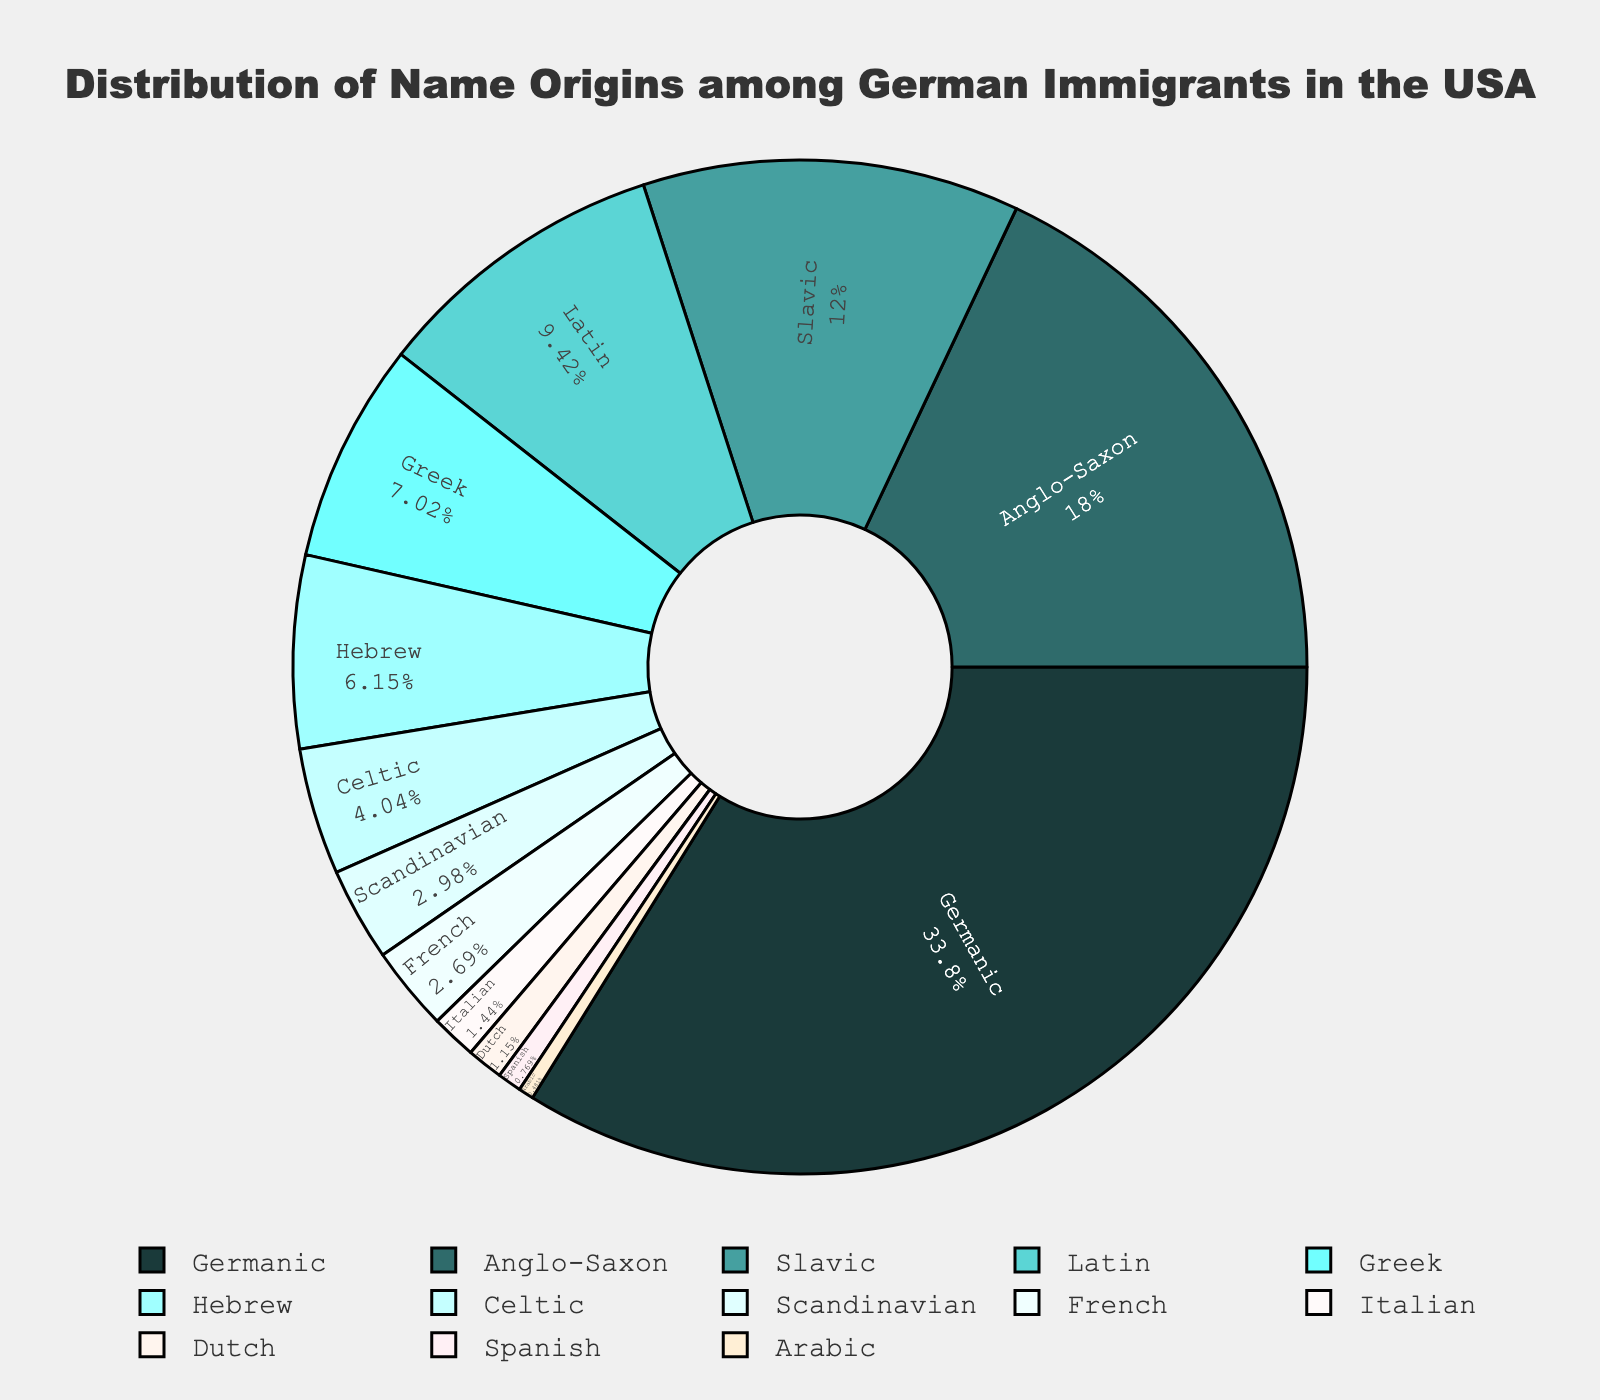What is the most common name origin among German immigrants in the USA? The figure shows the distribution of name origins, with the segment for 'Germanic' being the largest. This indicates that the most common name origin is Germanic.
Answer: Germanic What is the combined percentage of Anglo-Saxon and Slavic name origins among German immigrants in the USA? The figure shows that Anglo-Saxon has a percentage of 18.7% and Slavic has a percentage of 12.5%. Adding these together gives 18.7 + 12.5.
Answer: 31.2% Which name origin has a smaller percentage: Greek or Latin? The figure shows Greek with a percentage of 7.3% and Latin with a percentage of 9.8%. Therefore, Greek has a smaller percentage than Latin.
Answer: Greek How does the percentage of Celtic name origins compare to the percentage of Scandinavian name origins? The figure shows that Celtic is 4.2% and Scandinavian is 3.1%. Celtic has a higher percentage compared to Scandinavian.
Answer: Celtic is higher Which name origin is illustrated with the color green? The figure uses different colors for each name origin, with Scandinavian being represented by green.
Answer: Scandinavian What's the difference in percentage between Hebrew and French name origins? The figure shows that Hebrew has a percentage of 6.4% and French has a percentage of 2.8%. Subtracting these gives 6.4 - 2.8.
Answer: 3.6% Are there more name origins from Arabic or Dutch origin among German immigrants in the USA? The figure shows Arabic with a percentage of 0.5% and Dutch with a percentage of 1.2%. Dutch has a higher percentage compared to Arabic.
Answer: Dutch What's the total percentage of name origins that are neither Germanic nor Anglo-Saxon? The figure shows that Germanic is 35.2% and Anglo-Saxon is 18.7%. Subtracting these from 100% gives 100 - 35.2 - 18.7.
Answer: 46.1% What is the least common name origin among the German immigrants in the USA? The figure shows the smallest segment representing Spanish with a percentage of 0.8%.
Answer: Arabic 